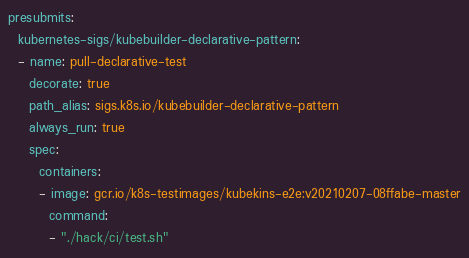Convert code to text. <code><loc_0><loc_0><loc_500><loc_500><_YAML_>presubmits:
  kubernetes-sigs/kubebuilder-declarative-pattern:
  - name: pull-declarative-test
    decorate: true
    path_alias: sigs.k8s.io/kubebuilder-declarative-pattern
    always_run: true
    spec:
      containers:
      - image: gcr.io/k8s-testimages/kubekins-e2e:v20210207-08ffabe-master
        command:
        - "./hack/ci/test.sh"
</code> 